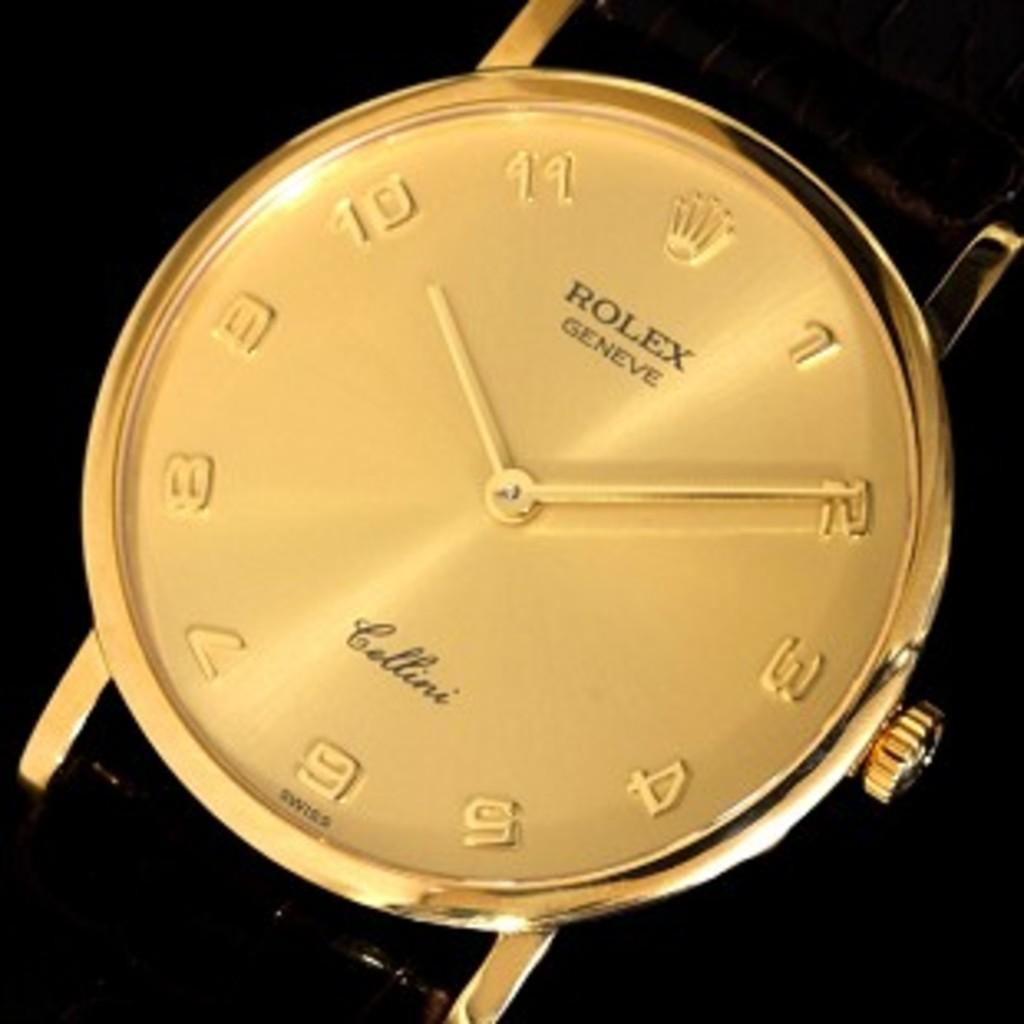<image>
Give a short and clear explanation of the subsequent image. the word rolex that is on a watch 